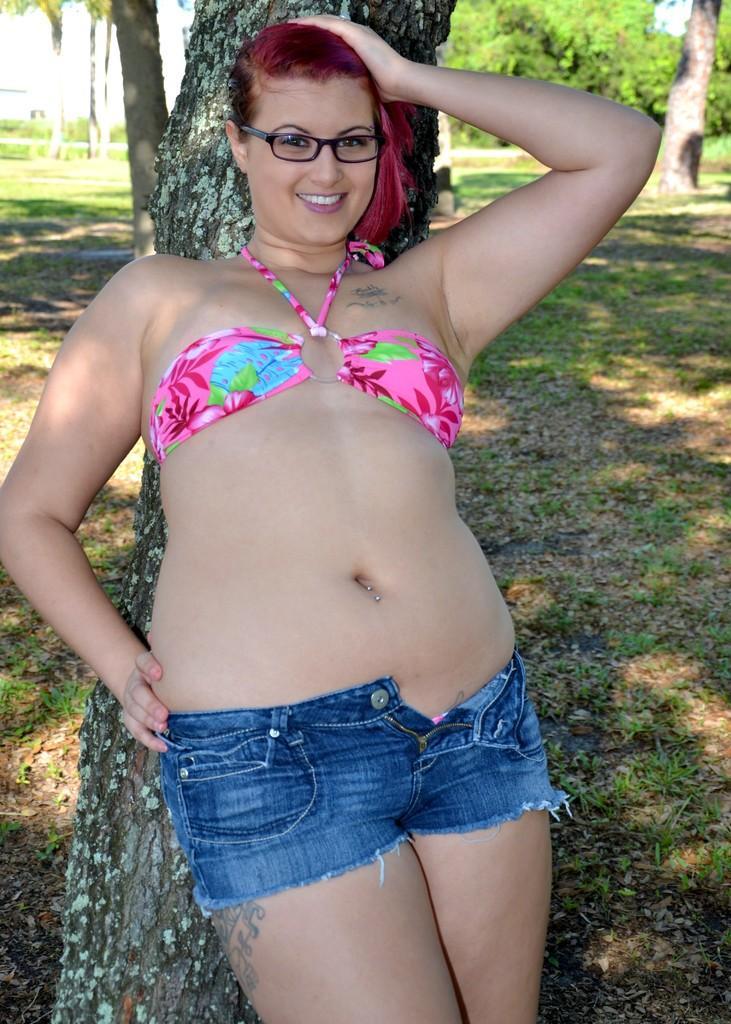In one or two sentences, can you explain what this image depicts? In the center of the image we can see a person standing at the tree. In the background there are many trees and grass. 